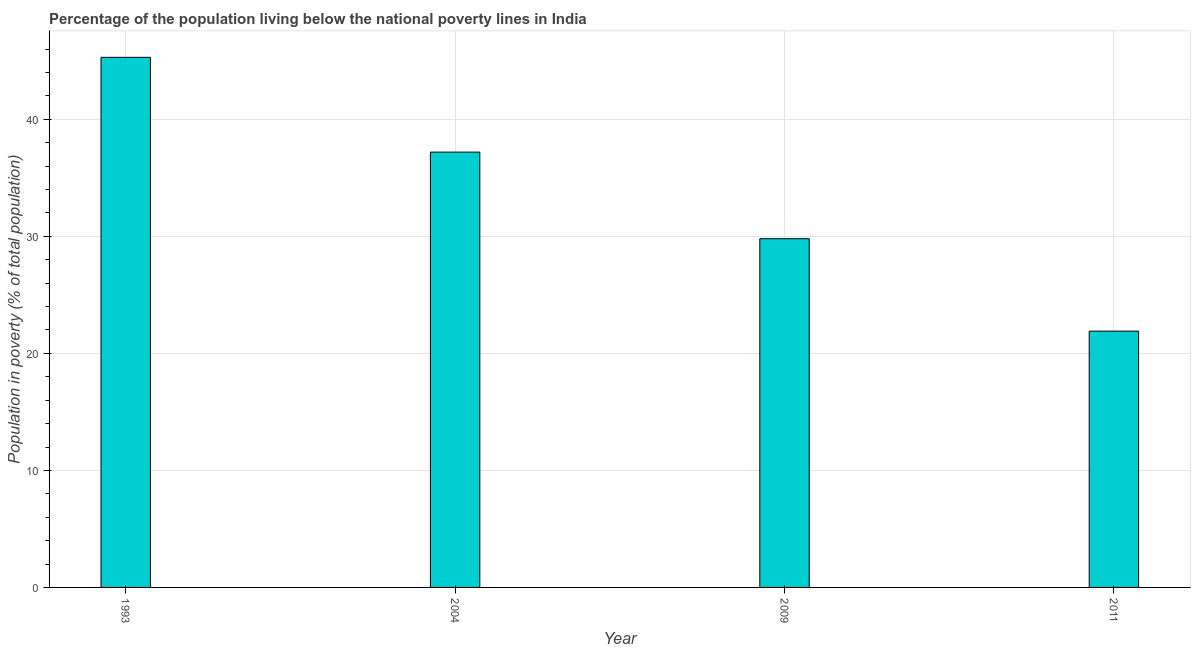What is the title of the graph?
Keep it short and to the point. Percentage of the population living below the national poverty lines in India. What is the label or title of the Y-axis?
Give a very brief answer. Population in poverty (% of total population). What is the percentage of population living below poverty line in 2004?
Offer a very short reply. 37.2. Across all years, what is the maximum percentage of population living below poverty line?
Your answer should be compact. 45.3. Across all years, what is the minimum percentage of population living below poverty line?
Your response must be concise. 21.9. In which year was the percentage of population living below poverty line maximum?
Your answer should be very brief. 1993. What is the sum of the percentage of population living below poverty line?
Provide a succinct answer. 134.2. What is the difference between the percentage of population living below poverty line in 1993 and 2009?
Ensure brevity in your answer.  15.5. What is the average percentage of population living below poverty line per year?
Your response must be concise. 33.55. What is the median percentage of population living below poverty line?
Make the answer very short. 33.5. Do a majority of the years between 2009 and 2011 (inclusive) have percentage of population living below poverty line greater than 10 %?
Provide a succinct answer. Yes. What is the ratio of the percentage of population living below poverty line in 2004 to that in 2011?
Give a very brief answer. 1.7. Is the difference between the percentage of population living below poverty line in 1993 and 2009 greater than the difference between any two years?
Keep it short and to the point. No. What is the difference between the highest and the lowest percentage of population living below poverty line?
Your response must be concise. 23.4. Are all the bars in the graph horizontal?
Offer a terse response. No. What is the difference between two consecutive major ticks on the Y-axis?
Your answer should be compact. 10. What is the Population in poverty (% of total population) of 1993?
Ensure brevity in your answer.  45.3. What is the Population in poverty (% of total population) of 2004?
Provide a succinct answer. 37.2. What is the Population in poverty (% of total population) in 2009?
Keep it short and to the point. 29.8. What is the Population in poverty (% of total population) in 2011?
Give a very brief answer. 21.9. What is the difference between the Population in poverty (% of total population) in 1993 and 2011?
Your response must be concise. 23.4. What is the ratio of the Population in poverty (% of total population) in 1993 to that in 2004?
Ensure brevity in your answer.  1.22. What is the ratio of the Population in poverty (% of total population) in 1993 to that in 2009?
Keep it short and to the point. 1.52. What is the ratio of the Population in poverty (% of total population) in 1993 to that in 2011?
Make the answer very short. 2.07. What is the ratio of the Population in poverty (% of total population) in 2004 to that in 2009?
Ensure brevity in your answer.  1.25. What is the ratio of the Population in poverty (% of total population) in 2004 to that in 2011?
Provide a succinct answer. 1.7. What is the ratio of the Population in poverty (% of total population) in 2009 to that in 2011?
Offer a very short reply. 1.36. 